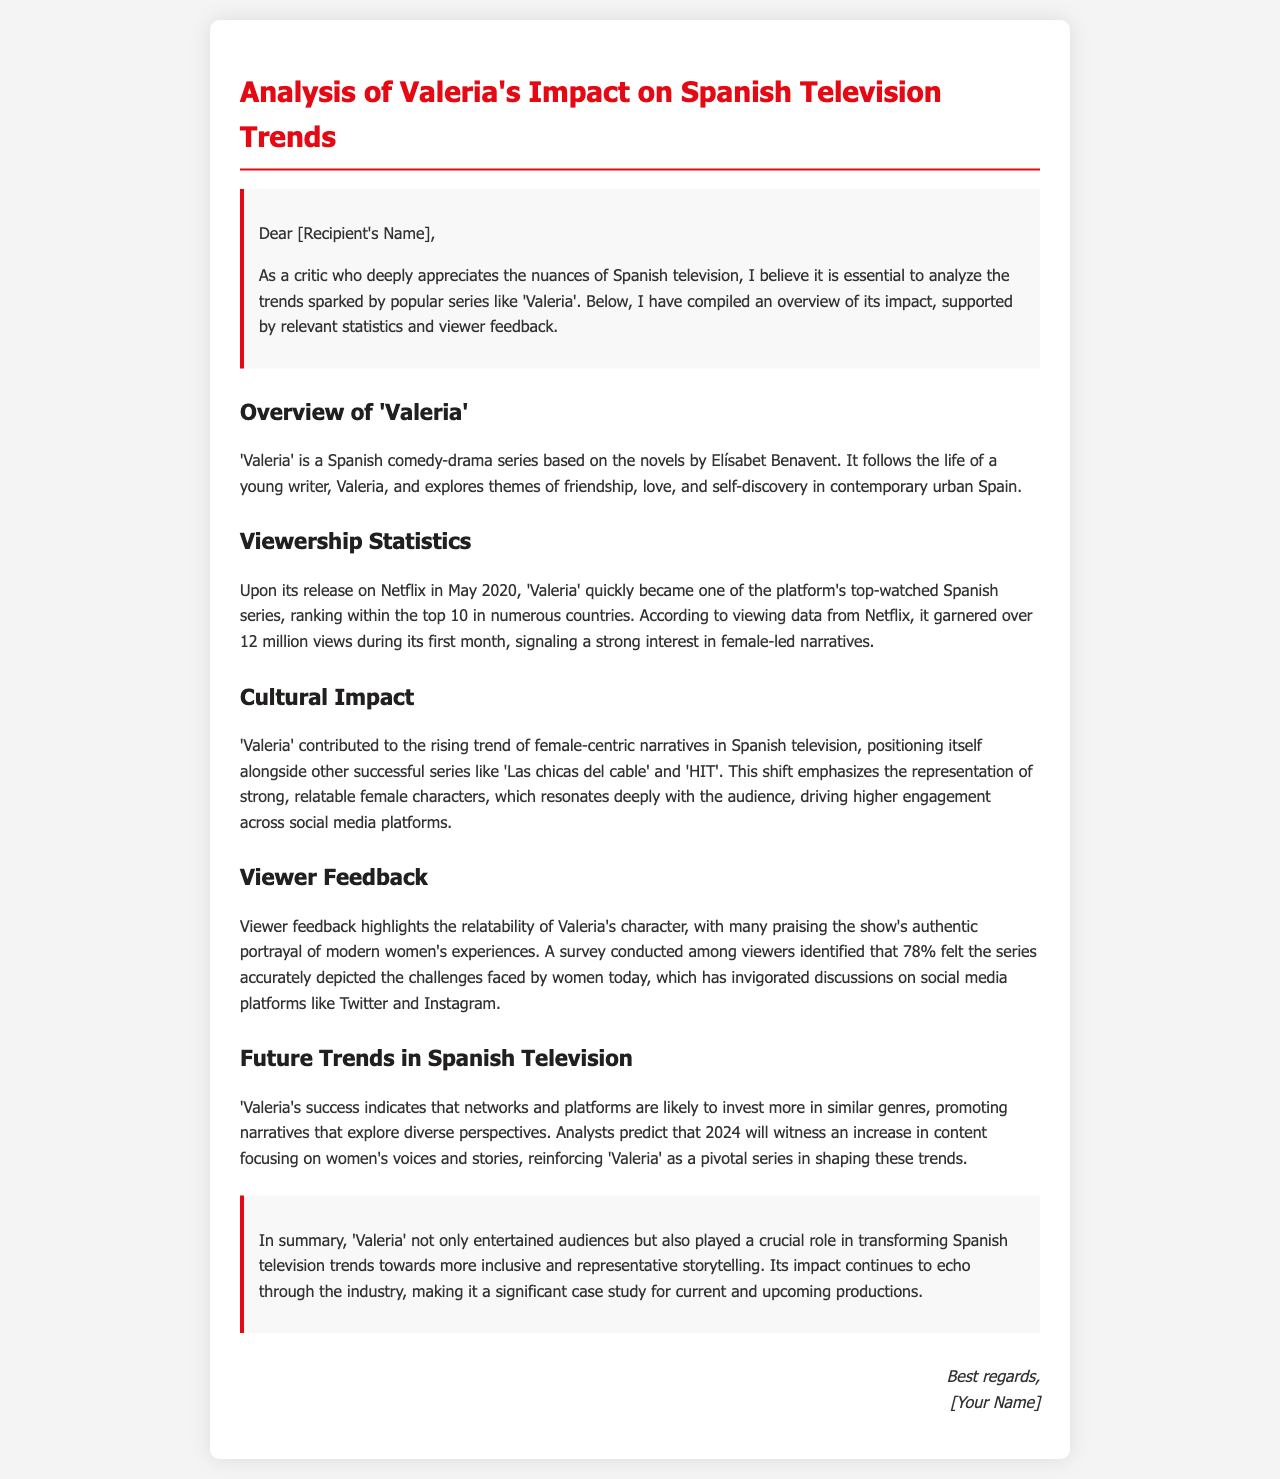What is the main genre of 'Valeria'? 'Valeria' is described as a comedy-drama series based on novels by Elísabet Benavent.
Answer: comedy-drama When was 'Valeria' released on Netflix? The document states 'Valeria' was released in May 2020.
Answer: May 2020 How many views did 'Valeria' garner in its first month? The document mentions that it garnered over 12 million views during its first month.
Answer: over 12 million What percentage of viewers felt the series accurately depicted women's challenges? A survey in the document shows that 78% of viewers felt the series depicted challenges accurately.
Answer: 78% Which other series is mentioned alongside 'Valeria' as part of female-centric narratives? The document lists 'Las chicas del cable' as another successful series.
Answer: Las chicas del cable What trend does 'Valeria's success indicate for future Spanish television content? The document suggests that networks are likely to invest more in narratives focusing on women's voices and stories.
Answer: women's voices and stories Who is the author of the novels on which 'Valeria' is based? The document attributes the novels to Elísabet Benavent.
Answer: Elísabet Benavent In what year is an increase in content focusing on women's narratives predicted? Analysts in the document predict that the year 2024 will see this increase.
Answer: 2024 